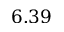<formula> <loc_0><loc_0><loc_500><loc_500>6 . 3 9</formula> 